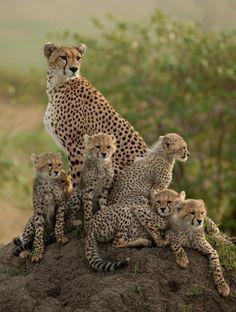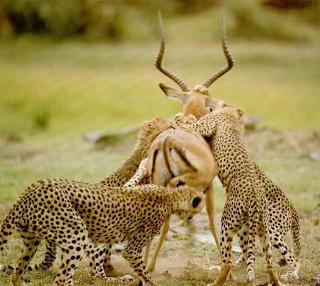The first image is the image on the left, the second image is the image on the right. Examine the images to the left and right. Is the description "You'll notice a handful of cheetah cubs in one of the images." accurate? Answer yes or no. Yes. 